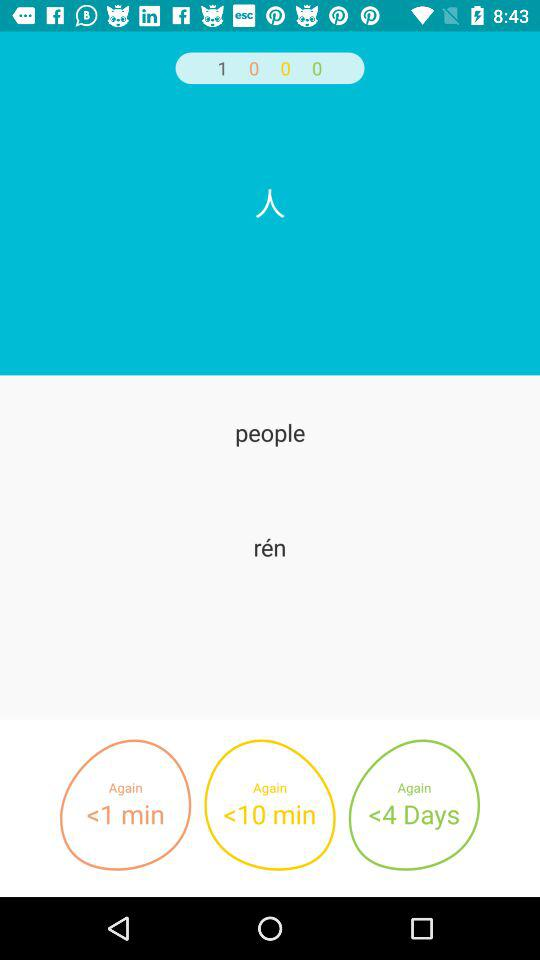How many numbers are less than 10 minutes?
Answer the question using a single word or phrase. 2 